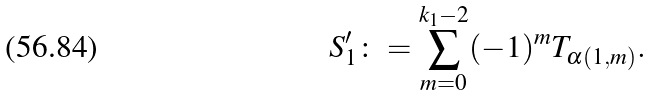<formula> <loc_0><loc_0><loc_500><loc_500>S ^ { \prime } _ { 1 } \colon = \sum _ { m = 0 } ^ { k _ { 1 } - 2 } ( - 1 ) ^ { m } T _ { \alpha ( 1 , m ) } .</formula> 